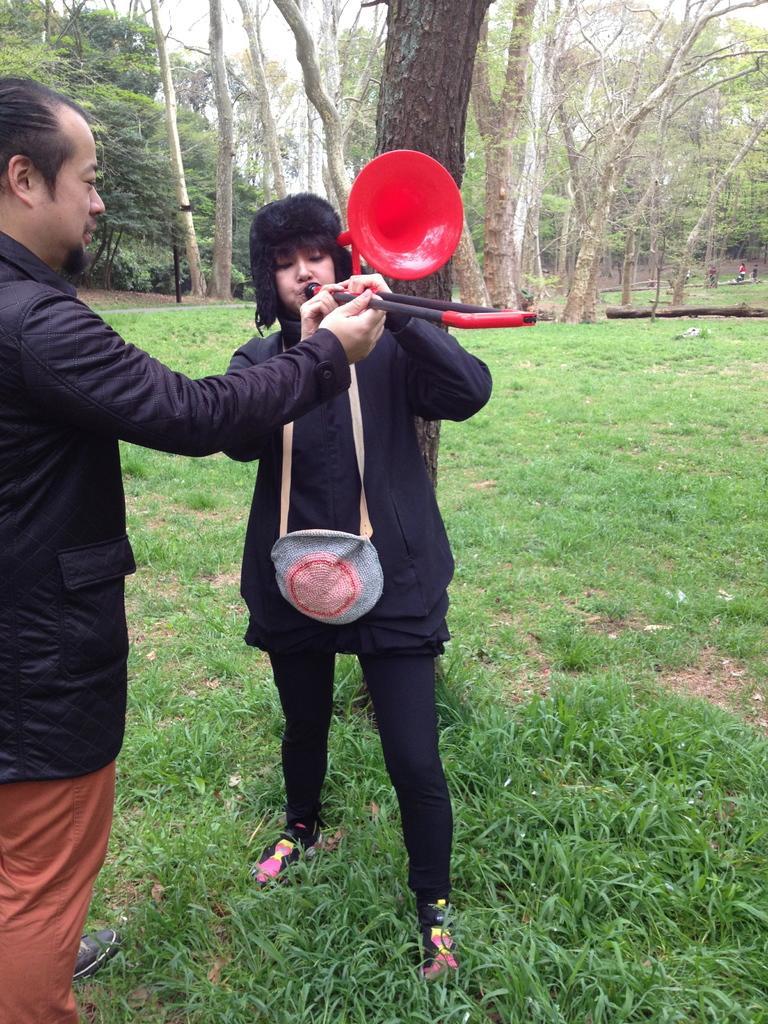Can you describe this image briefly? In front of the picture, we see a woman who is wearing a bag is standing and she is holding an object which looks like a trumpet. It is in red and black color. On the left side, we see a man is standing and he is holding an object which looks like a trumpet. At the bottom, we see the grass. There are trees in the background. 